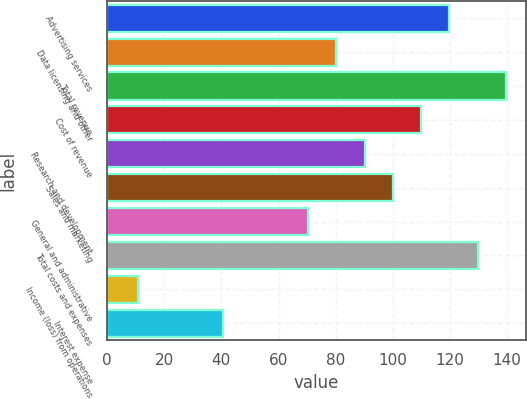<chart> <loc_0><loc_0><loc_500><loc_500><bar_chart><fcel>Advertising services<fcel>Data licensing and other<fcel>Total revenue<fcel>Cost of revenue<fcel>Research and development<fcel>Sales and marketing<fcel>General and administrative<fcel>Total costs and expenses<fcel>Income (loss) from operations<fcel>Interest expense<nl><fcel>119.8<fcel>80.2<fcel>139.6<fcel>109.9<fcel>90.1<fcel>100<fcel>70.3<fcel>129.7<fcel>10.9<fcel>40.6<nl></chart> 